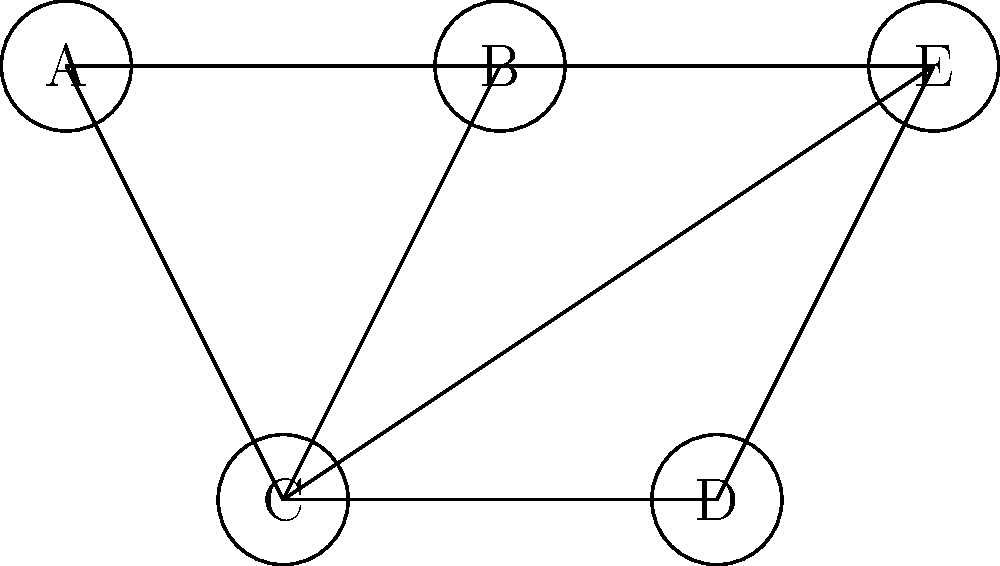A comedian is planning their early tour dates across five cities (A, B, C, D, and E). The graph represents the conflicts between shows, where an edge between two nodes means the shows cannot be scheduled on the same day. What is the minimum number of days needed to schedule all shows without conflicts? To solve this problem, we need to use graph coloring techniques. Each color represents a different day, and we want to minimize the number of colors used while ensuring no two adjacent nodes have the same color.

Step 1: Analyze the graph structure.
- The graph has 5 nodes (A, B, C, D, E) representing cities.
- There are 7 edges representing conflicts between shows.

Step 2: Apply the greedy coloring algorithm.
1. Start with node A and assign it color 1.
2. Move to node B. It's connected to A, so assign it color 2.
3. For node C:
   - It's connected to A and B, so we need a new color. Assign color 3.
4. For node D:
   - It's only connected to C, so we can use color 1 or 2. Assign color 1.
5. For node E:
   - It's connected to B and C, so we can use color 1. Assign color 1.

Step 3: Count the number of colors used.
We used 3 colors in total, which means we need a minimum of 3 days to schedule all shows without conflicts.

This solution is optimal because the graph contains a triangle (A-B-C), which requires at least 3 colors.
Answer: 3 days 